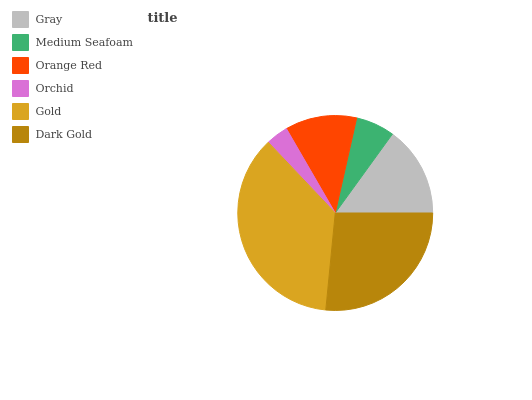Is Orchid the minimum?
Answer yes or no. Yes. Is Gold the maximum?
Answer yes or no. Yes. Is Medium Seafoam the minimum?
Answer yes or no. No. Is Medium Seafoam the maximum?
Answer yes or no. No. Is Gray greater than Medium Seafoam?
Answer yes or no. Yes. Is Medium Seafoam less than Gray?
Answer yes or no. Yes. Is Medium Seafoam greater than Gray?
Answer yes or no. No. Is Gray less than Medium Seafoam?
Answer yes or no. No. Is Gray the high median?
Answer yes or no. Yes. Is Orange Red the low median?
Answer yes or no. Yes. Is Medium Seafoam the high median?
Answer yes or no. No. Is Medium Seafoam the low median?
Answer yes or no. No. 